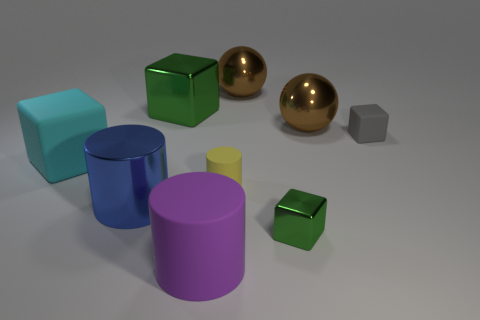What number of large shiny objects are both in front of the small yellow matte object and behind the large green cube?
Keep it short and to the point. 0. Do the gray block and the green cube that is in front of the big green object have the same size?
Your response must be concise. Yes. Is there a brown thing that is in front of the large thing that is in front of the metallic cube that is on the right side of the big purple rubber cylinder?
Offer a terse response. No. What is the material of the green block in front of the tiny rubber object that is behind the large cyan matte cube?
Give a very brief answer. Metal. What is the thing that is both behind the big purple cylinder and in front of the large blue object made of?
Make the answer very short. Metal. Are there any other tiny green shiny things of the same shape as the small green object?
Offer a very short reply. No. There is a rubber cube that is on the right side of the tiny yellow rubber cylinder; are there any tiny matte blocks to the left of it?
Your answer should be very brief. No. What number of tiny cylinders are made of the same material as the large green block?
Ensure brevity in your answer.  0. Is there a blue shiny cylinder?
Your response must be concise. Yes. How many small objects have the same color as the small cylinder?
Offer a terse response. 0. 